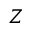<formula> <loc_0><loc_0><loc_500><loc_500>Z</formula> 